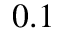<formula> <loc_0><loc_0><loc_500><loc_500>0 . 1</formula> 